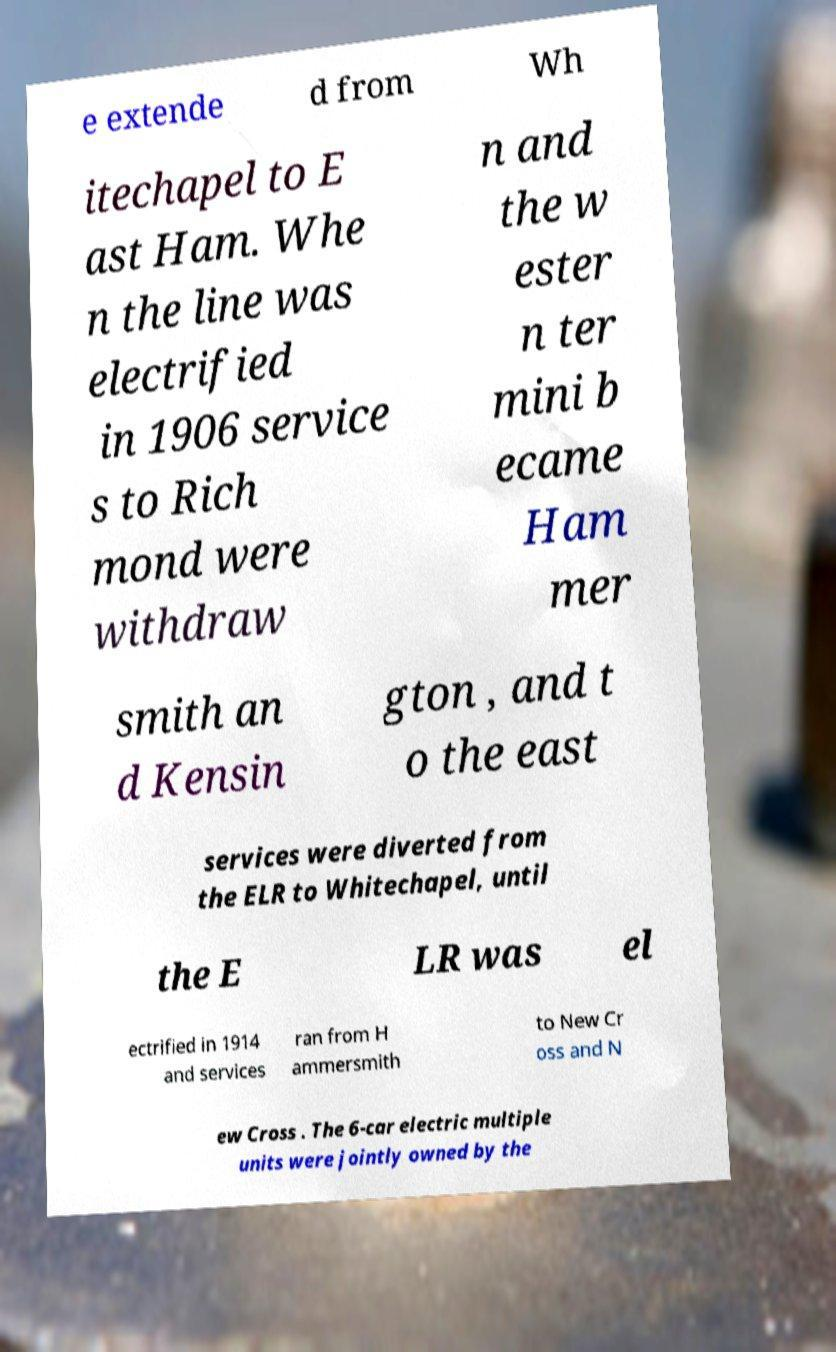What messages or text are displayed in this image? I need them in a readable, typed format. e extende d from Wh itechapel to E ast Ham. Whe n the line was electrified in 1906 service s to Rich mond were withdraw n and the w ester n ter mini b ecame Ham mer smith an d Kensin gton , and t o the east services were diverted from the ELR to Whitechapel, until the E LR was el ectrified in 1914 and services ran from H ammersmith to New Cr oss and N ew Cross . The 6-car electric multiple units were jointly owned by the 